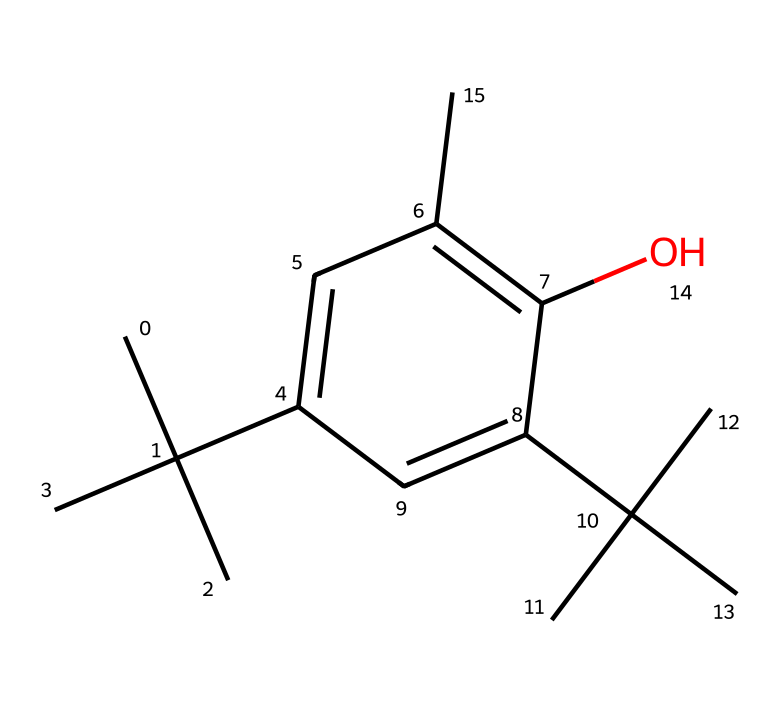What is the functional group present in this chemical? The chemical contains a hydroxyl group (-OH) attached to an aromatic ring, which identifies it as a phenol.
Answer: hydroxyl How many carbon atoms are in this chemical structure? By analyzing the SMILES notation, we can count the number of 'C' entries. There are 15 carbon atoms in total.
Answer: 15 What type of chemical is represented by this SMILES? The structure fits the characteristics of phenolic compounds due to the presence of a hydroxyl group on an aromatic ring.
Answer: phenol What is the degree of unsaturation in this compound? The unsaturation can be determined based on the number of double bonds and rings. This compound has 2 double bonds and 1 ring, resulting in 3 degrees of unsaturation.
Answer: 3 Does this compound have any substituents? Examining the structure, we can see tert-butyl groups as substituents on the aromatic ring, indicating other attached groups enhancing its properties.
Answer: yes What is the primary reason for using phenol-based preservatives in office furniture coatings? Phenol-based preservatives are often employed due to their effectiveness against microbial growth and their stability in coatings.
Answer: effectiveness 